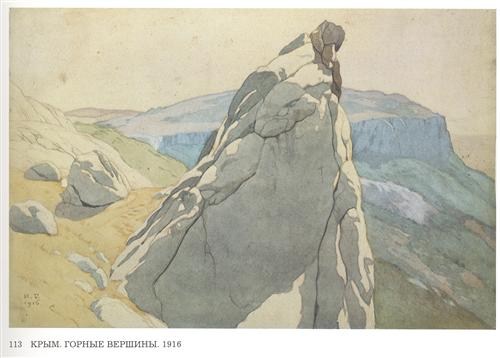Analyze the image in a comprehensive and detailed manner. This is a watercolor painting from 1916, notable for its realistic representation and serene atmosphere created by muted colors. The foreground prominently features a rocky cliff, integral to the Crimean Mountains. This range extends into the background, adding depth to the composition. As a landscape painting, it adeptly captures natural scenery, reflecting both artistic skill and an appreciation for tranquil, mountainous vistas. 